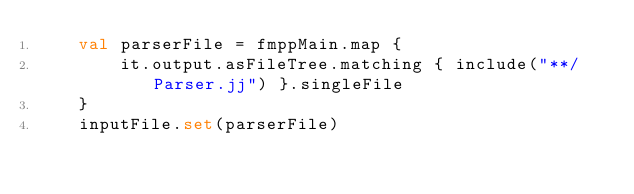<code> <loc_0><loc_0><loc_500><loc_500><_Kotlin_>    val parserFile = fmppMain.map {
        it.output.asFileTree.matching { include("**/Parser.jj") }.singleFile
    }
    inputFile.set(parserFile)</code> 